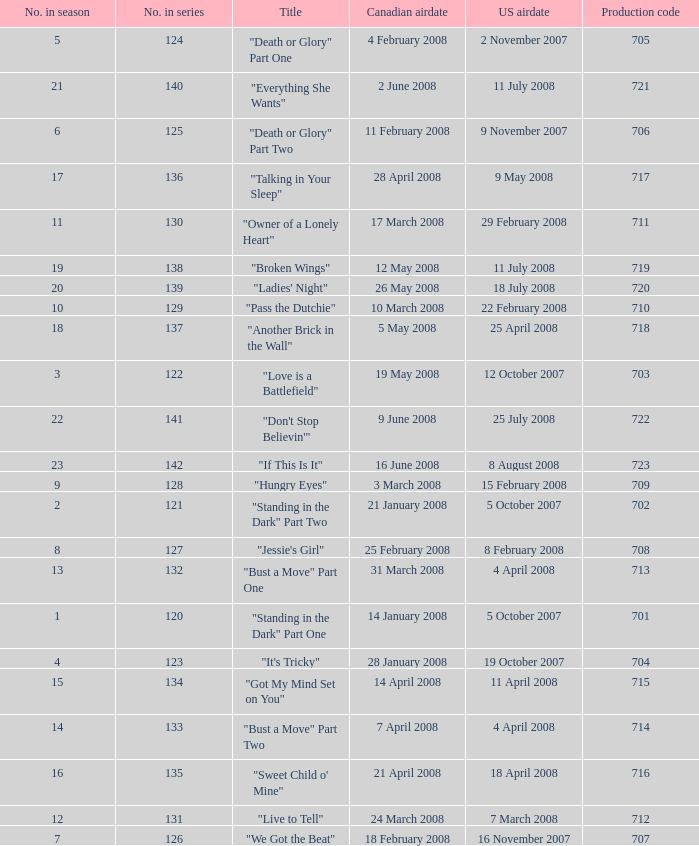For the episode(s) aired in the U.S. on 4 april 2008, what were the names? "Bust a Move" Part One, "Bust a Move" Part Two. 